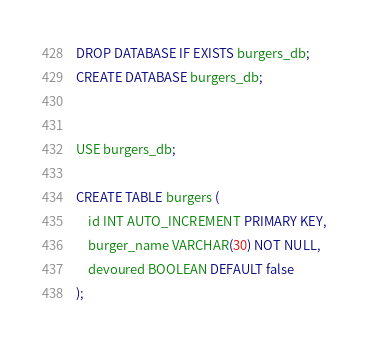<code> <loc_0><loc_0><loc_500><loc_500><_SQL_>DROP DATABASE IF EXISTS burgers_db;
CREATE DATABASE burgers_db;


USE burgers_db;

CREATE TABLE burgers (
    id INT AUTO_INCREMENT PRIMARY KEY,
    burger_name VARCHAR(30) NOT NULL,
    devoured BOOLEAN DEFAULT false
);


</code> 